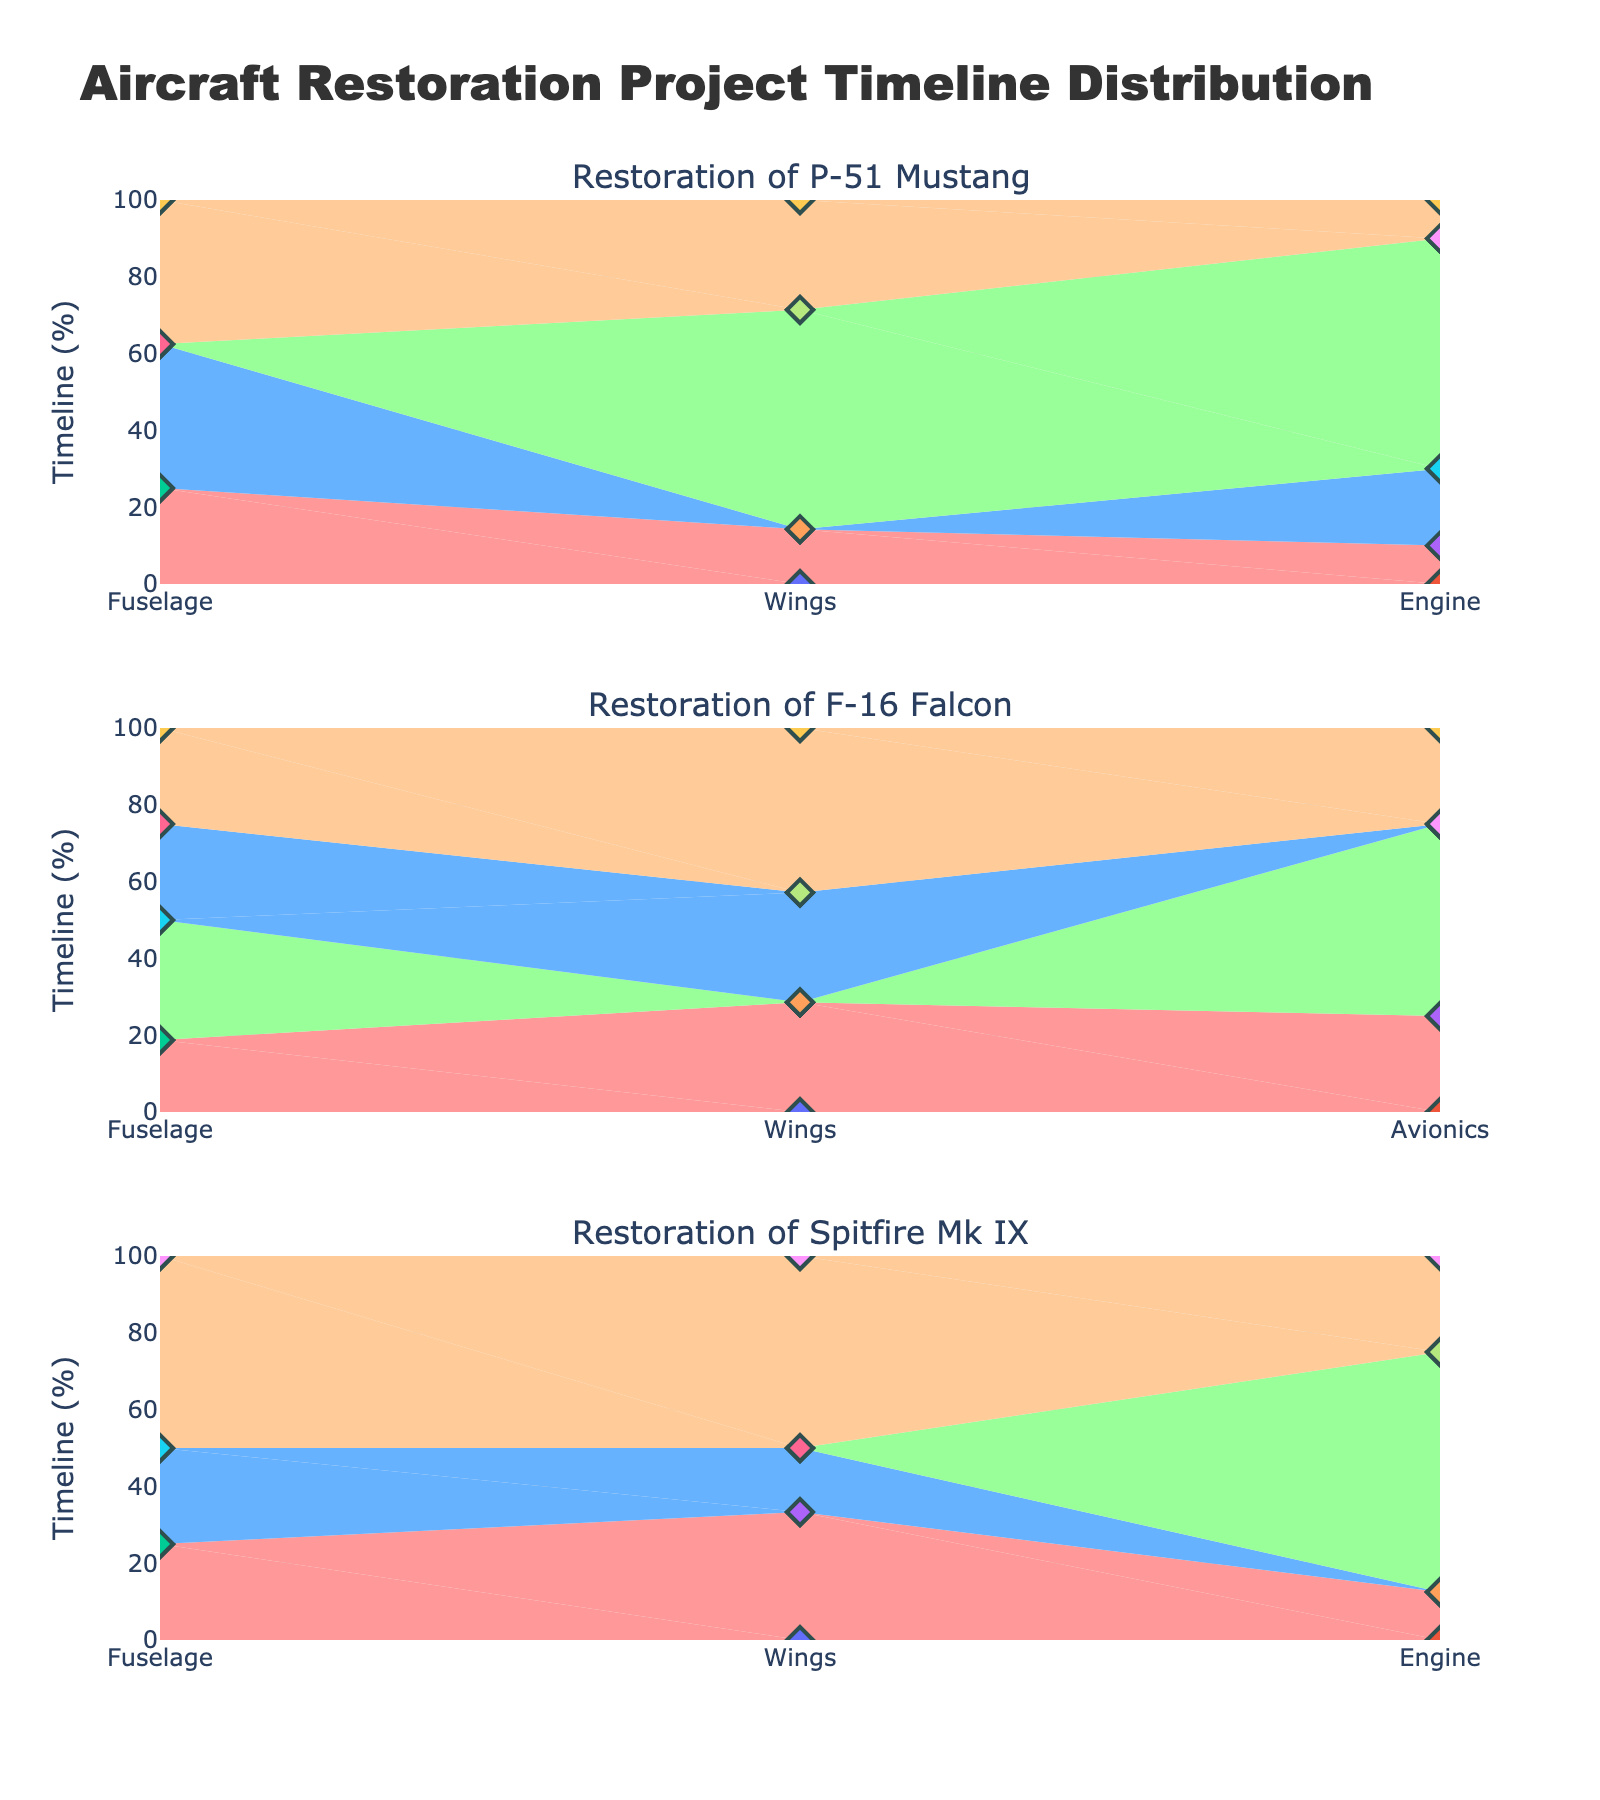What is the title of the chart? The title is shown at the top of the chart, displayed prominently. It is directly related to the subject matter of the visualized data.
Answer: Aircraft Restoration Project Timeline Distribution What is the color used to represent the "Repair" phase? Each phase is visually distinct with a unique color based on the provided legend. The color assigned to the "Repair" phase can be identified by matching the colored components in the visual representation.
Answer: Light Green Which aircraft has the longest inspection phase for the fuselage? By comparing the duration of the inspection phase for the fuselage across all aircraft in the respective subplot, we can determine the maximum value.
Answer: F-16 Falcon How many weeks are spent on the dismantling phase of the P-51 Mustang's engine? Locate the subplot for the P-51 Mustang and identify the dismantling phase for the engine component. The corresponding timeline value indicates the weeks spent.
Answer: 2 weeks In the restoration of Spitfire Mk IX, which component has the longest timeline in the repair phase? By examining the repair phase in the subplot for Spitfire Mk IX, we compare the duration for each component and identify the maximum value.
Answer: Engine Compare the total weeks spent on the assembly phase for the F-16 Falcon and the Spitfire Mk IX. Which one takes longer? Sum the timeline values for all components in the assembly phase for both F-16 Falcon and Spitfire Mk IX. Then compare the total weeks of each aircraft's assembly phase.
Answer: F-16 Falcon Which phase in the restoration of the P-51 Mustang takes the shortest amount of time overall? By summing up the duration of all components in each phase for the P-51 Mustang and comparing the total timelines, we can determine the phase with the minimum overall time.
Answer: Inspection What percentage of time is allocated to the repair phase of the engine in the restoration of Spitfire Mk IX? Calculate the timeline for the repair phase of the engine relative to the total repair timeline for all components and convert it into a percentage.
Answer: 50% Across all three aircraft, which phase has the most uniform distribution in terms of timeline weeks? Evaluate the timeline values of each phase across all aircrafts and determine which phase has the most consistent timeline distribution among various components.
Answer: Inspection 